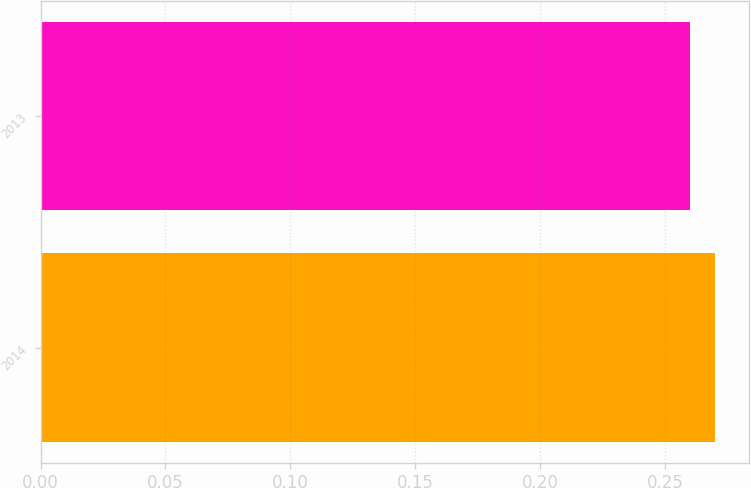Convert chart. <chart><loc_0><loc_0><loc_500><loc_500><bar_chart><fcel>2014<fcel>2013<nl><fcel>0.27<fcel>0.26<nl></chart> 